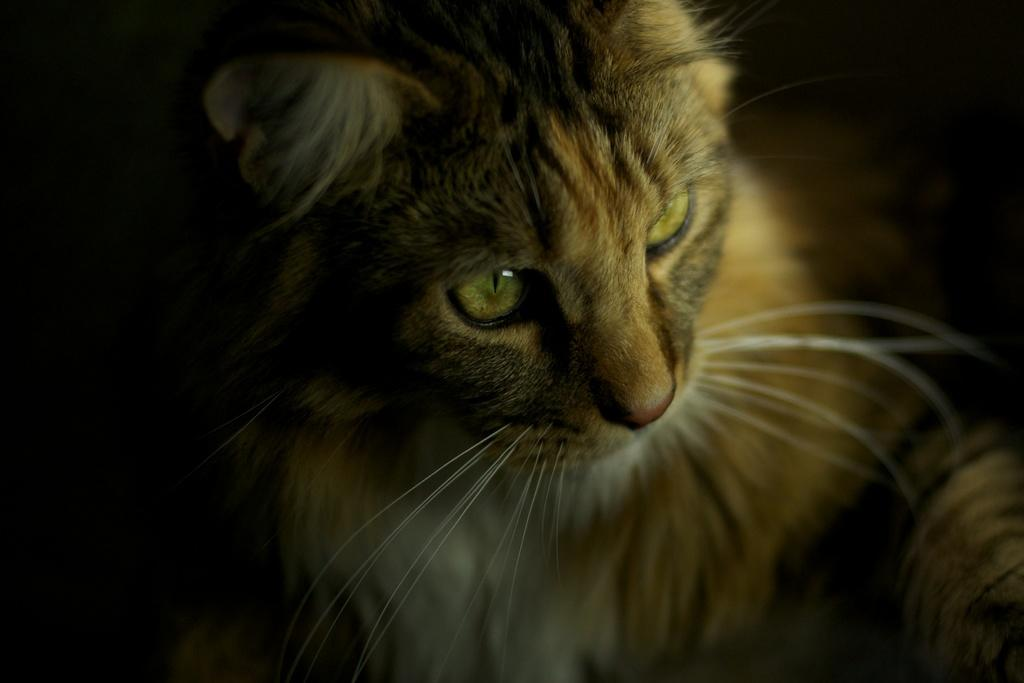What type of animal is in the image? There is a cat in the image. What color is the background of the image? The background of the image is black. What type of marble is visible in the image? There is no marble present in the image. What month is it in the image? The image does not provide any information about the month. 